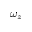Convert formula to latex. <formula><loc_0><loc_0><loc_500><loc_500>\omega _ { z }</formula> 